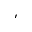<formula> <loc_0><loc_0><loc_500><loc_500>^ { \prime }</formula> 